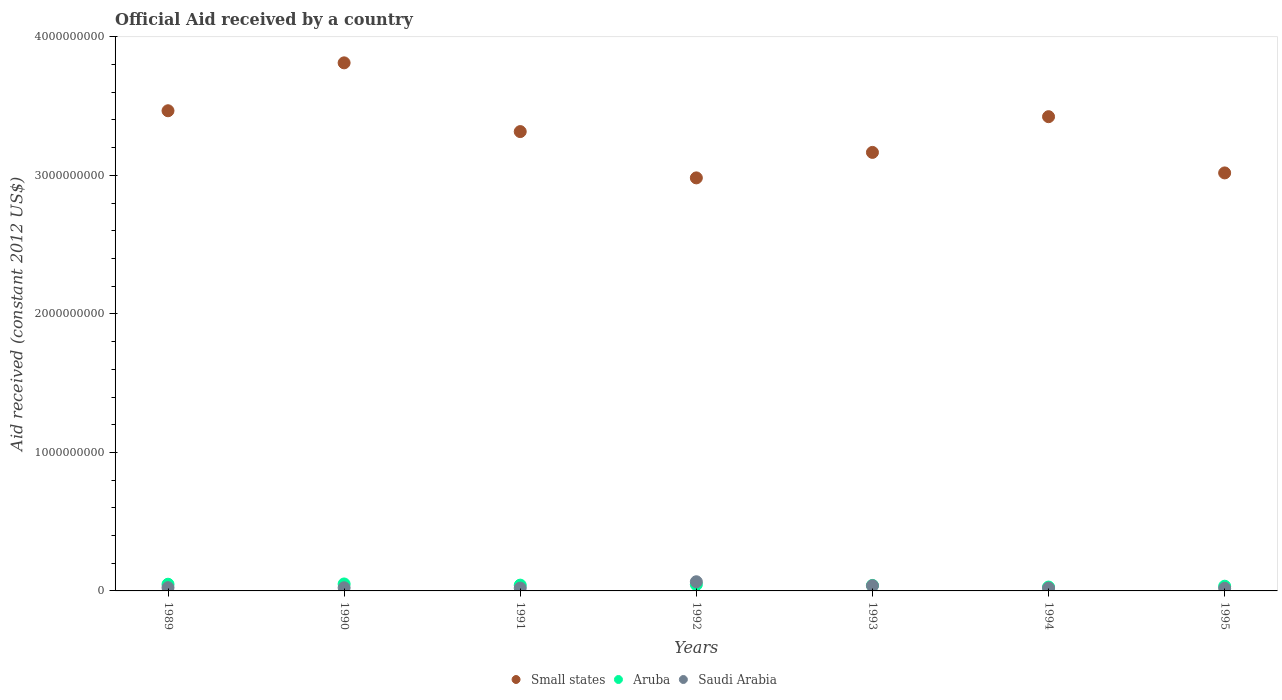How many different coloured dotlines are there?
Provide a short and direct response. 3. Is the number of dotlines equal to the number of legend labels?
Give a very brief answer. Yes. What is the net official aid received in Small states in 1995?
Offer a terse response. 3.02e+09. Across all years, what is the maximum net official aid received in Saudi Arabia?
Your answer should be very brief. 6.62e+07. Across all years, what is the minimum net official aid received in Saudi Arabia?
Ensure brevity in your answer.  1.89e+07. In which year was the net official aid received in Aruba maximum?
Provide a succinct answer. 1990. In which year was the net official aid received in Small states minimum?
Ensure brevity in your answer.  1992. What is the total net official aid received in Aruba in the graph?
Your answer should be very brief. 2.88e+08. What is the difference between the net official aid received in Saudi Arabia in 1989 and that in 1992?
Ensure brevity in your answer.  -4.27e+07. What is the difference between the net official aid received in Aruba in 1993 and the net official aid received in Small states in 1992?
Ensure brevity in your answer.  -2.94e+09. What is the average net official aid received in Saudi Arabia per year?
Ensure brevity in your answer.  3.00e+07. In the year 1990, what is the difference between the net official aid received in Small states and net official aid received in Saudi Arabia?
Offer a terse response. 3.79e+09. What is the ratio of the net official aid received in Aruba in 1989 to that in 1994?
Give a very brief answer. 1.74. Is the net official aid received in Small states in 1992 less than that in 1995?
Your response must be concise. Yes. Is the difference between the net official aid received in Small states in 1992 and 1993 greater than the difference between the net official aid received in Saudi Arabia in 1992 and 1993?
Provide a short and direct response. No. What is the difference between the highest and the second highest net official aid received in Aruba?
Give a very brief answer. 1.97e+06. What is the difference between the highest and the lowest net official aid received in Aruba?
Your response must be concise. 2.24e+07. Does the net official aid received in Aruba monotonically increase over the years?
Give a very brief answer. No. How many years are there in the graph?
Give a very brief answer. 7. Are the values on the major ticks of Y-axis written in scientific E-notation?
Your response must be concise. No. Where does the legend appear in the graph?
Offer a terse response. Bottom center. How many legend labels are there?
Your response must be concise. 3. What is the title of the graph?
Give a very brief answer. Official Aid received by a country. What is the label or title of the Y-axis?
Your response must be concise. Aid received (constant 2012 US$). What is the Aid received (constant 2012 US$) of Small states in 1989?
Provide a succinct answer. 3.47e+09. What is the Aid received (constant 2012 US$) in Aruba in 1989?
Make the answer very short. 4.83e+07. What is the Aid received (constant 2012 US$) of Saudi Arabia in 1989?
Ensure brevity in your answer.  2.34e+07. What is the Aid received (constant 2012 US$) of Small states in 1990?
Your response must be concise. 3.81e+09. What is the Aid received (constant 2012 US$) of Aruba in 1990?
Give a very brief answer. 5.03e+07. What is the Aid received (constant 2012 US$) of Saudi Arabia in 1990?
Make the answer very short. 2.27e+07. What is the Aid received (constant 2012 US$) of Small states in 1991?
Your response must be concise. 3.32e+09. What is the Aid received (constant 2012 US$) of Aruba in 1991?
Make the answer very short. 4.18e+07. What is the Aid received (constant 2012 US$) in Saudi Arabia in 1991?
Keep it short and to the point. 2.04e+07. What is the Aid received (constant 2012 US$) of Small states in 1992?
Your answer should be compact. 2.98e+09. What is the Aid received (constant 2012 US$) in Aruba in 1992?
Offer a very short reply. 4.60e+07. What is the Aid received (constant 2012 US$) in Saudi Arabia in 1992?
Provide a succinct answer. 6.62e+07. What is the Aid received (constant 2012 US$) of Small states in 1993?
Give a very brief answer. 3.17e+09. What is the Aid received (constant 2012 US$) of Aruba in 1993?
Your answer should be compact. 3.96e+07. What is the Aid received (constant 2012 US$) of Saudi Arabia in 1993?
Your answer should be compact. 3.77e+07. What is the Aid received (constant 2012 US$) in Small states in 1994?
Ensure brevity in your answer.  3.42e+09. What is the Aid received (constant 2012 US$) in Aruba in 1994?
Ensure brevity in your answer.  2.78e+07. What is the Aid received (constant 2012 US$) of Saudi Arabia in 1994?
Your answer should be very brief. 2.06e+07. What is the Aid received (constant 2012 US$) of Small states in 1995?
Keep it short and to the point. 3.02e+09. What is the Aid received (constant 2012 US$) of Aruba in 1995?
Provide a short and direct response. 3.40e+07. What is the Aid received (constant 2012 US$) in Saudi Arabia in 1995?
Make the answer very short. 1.89e+07. Across all years, what is the maximum Aid received (constant 2012 US$) of Small states?
Offer a very short reply. 3.81e+09. Across all years, what is the maximum Aid received (constant 2012 US$) of Aruba?
Offer a terse response. 5.03e+07. Across all years, what is the maximum Aid received (constant 2012 US$) in Saudi Arabia?
Give a very brief answer. 6.62e+07. Across all years, what is the minimum Aid received (constant 2012 US$) in Small states?
Offer a very short reply. 2.98e+09. Across all years, what is the minimum Aid received (constant 2012 US$) of Aruba?
Ensure brevity in your answer.  2.78e+07. Across all years, what is the minimum Aid received (constant 2012 US$) in Saudi Arabia?
Provide a short and direct response. 1.89e+07. What is the total Aid received (constant 2012 US$) of Small states in the graph?
Ensure brevity in your answer.  2.32e+1. What is the total Aid received (constant 2012 US$) of Aruba in the graph?
Keep it short and to the point. 2.88e+08. What is the total Aid received (constant 2012 US$) in Saudi Arabia in the graph?
Keep it short and to the point. 2.10e+08. What is the difference between the Aid received (constant 2012 US$) in Small states in 1989 and that in 1990?
Ensure brevity in your answer.  -3.46e+08. What is the difference between the Aid received (constant 2012 US$) of Aruba in 1989 and that in 1990?
Your response must be concise. -1.97e+06. What is the difference between the Aid received (constant 2012 US$) of Small states in 1989 and that in 1991?
Give a very brief answer. 1.50e+08. What is the difference between the Aid received (constant 2012 US$) of Aruba in 1989 and that in 1991?
Give a very brief answer. 6.55e+06. What is the difference between the Aid received (constant 2012 US$) of Saudi Arabia in 1989 and that in 1991?
Ensure brevity in your answer.  3.03e+06. What is the difference between the Aid received (constant 2012 US$) in Small states in 1989 and that in 1992?
Offer a terse response. 4.85e+08. What is the difference between the Aid received (constant 2012 US$) in Aruba in 1989 and that in 1992?
Make the answer very short. 2.31e+06. What is the difference between the Aid received (constant 2012 US$) in Saudi Arabia in 1989 and that in 1992?
Give a very brief answer. -4.27e+07. What is the difference between the Aid received (constant 2012 US$) of Small states in 1989 and that in 1993?
Your answer should be compact. 3.01e+08. What is the difference between the Aid received (constant 2012 US$) of Aruba in 1989 and that in 1993?
Your answer should be compact. 8.76e+06. What is the difference between the Aid received (constant 2012 US$) in Saudi Arabia in 1989 and that in 1993?
Keep it short and to the point. -1.42e+07. What is the difference between the Aid received (constant 2012 US$) in Small states in 1989 and that in 1994?
Make the answer very short. 4.28e+07. What is the difference between the Aid received (constant 2012 US$) in Aruba in 1989 and that in 1994?
Keep it short and to the point. 2.05e+07. What is the difference between the Aid received (constant 2012 US$) of Saudi Arabia in 1989 and that in 1994?
Offer a very short reply. 2.83e+06. What is the difference between the Aid received (constant 2012 US$) of Small states in 1989 and that in 1995?
Provide a succinct answer. 4.49e+08. What is the difference between the Aid received (constant 2012 US$) in Aruba in 1989 and that in 1995?
Keep it short and to the point. 1.43e+07. What is the difference between the Aid received (constant 2012 US$) in Saudi Arabia in 1989 and that in 1995?
Make the answer very short. 4.52e+06. What is the difference between the Aid received (constant 2012 US$) of Small states in 1990 and that in 1991?
Your answer should be very brief. 4.96e+08. What is the difference between the Aid received (constant 2012 US$) in Aruba in 1990 and that in 1991?
Make the answer very short. 8.52e+06. What is the difference between the Aid received (constant 2012 US$) of Saudi Arabia in 1990 and that in 1991?
Your answer should be very brief. 2.33e+06. What is the difference between the Aid received (constant 2012 US$) of Small states in 1990 and that in 1992?
Keep it short and to the point. 8.31e+08. What is the difference between the Aid received (constant 2012 US$) in Aruba in 1990 and that in 1992?
Offer a very short reply. 4.28e+06. What is the difference between the Aid received (constant 2012 US$) in Saudi Arabia in 1990 and that in 1992?
Your response must be concise. -4.34e+07. What is the difference between the Aid received (constant 2012 US$) of Small states in 1990 and that in 1993?
Provide a succinct answer. 6.47e+08. What is the difference between the Aid received (constant 2012 US$) in Aruba in 1990 and that in 1993?
Your response must be concise. 1.07e+07. What is the difference between the Aid received (constant 2012 US$) in Saudi Arabia in 1990 and that in 1993?
Provide a succinct answer. -1.50e+07. What is the difference between the Aid received (constant 2012 US$) of Small states in 1990 and that in 1994?
Give a very brief answer. 3.89e+08. What is the difference between the Aid received (constant 2012 US$) of Aruba in 1990 and that in 1994?
Your answer should be compact. 2.24e+07. What is the difference between the Aid received (constant 2012 US$) in Saudi Arabia in 1990 and that in 1994?
Keep it short and to the point. 2.13e+06. What is the difference between the Aid received (constant 2012 US$) of Small states in 1990 and that in 1995?
Ensure brevity in your answer.  7.95e+08. What is the difference between the Aid received (constant 2012 US$) of Aruba in 1990 and that in 1995?
Your answer should be very brief. 1.63e+07. What is the difference between the Aid received (constant 2012 US$) of Saudi Arabia in 1990 and that in 1995?
Offer a terse response. 3.82e+06. What is the difference between the Aid received (constant 2012 US$) of Small states in 1991 and that in 1992?
Ensure brevity in your answer.  3.34e+08. What is the difference between the Aid received (constant 2012 US$) in Aruba in 1991 and that in 1992?
Make the answer very short. -4.24e+06. What is the difference between the Aid received (constant 2012 US$) of Saudi Arabia in 1991 and that in 1992?
Give a very brief answer. -4.58e+07. What is the difference between the Aid received (constant 2012 US$) in Small states in 1991 and that in 1993?
Your answer should be compact. 1.50e+08. What is the difference between the Aid received (constant 2012 US$) in Aruba in 1991 and that in 1993?
Make the answer very short. 2.21e+06. What is the difference between the Aid received (constant 2012 US$) in Saudi Arabia in 1991 and that in 1993?
Make the answer very short. -1.73e+07. What is the difference between the Aid received (constant 2012 US$) in Small states in 1991 and that in 1994?
Your answer should be compact. -1.08e+08. What is the difference between the Aid received (constant 2012 US$) of Aruba in 1991 and that in 1994?
Keep it short and to the point. 1.39e+07. What is the difference between the Aid received (constant 2012 US$) of Small states in 1991 and that in 1995?
Ensure brevity in your answer.  2.98e+08. What is the difference between the Aid received (constant 2012 US$) in Aruba in 1991 and that in 1995?
Your answer should be very brief. 7.74e+06. What is the difference between the Aid received (constant 2012 US$) of Saudi Arabia in 1991 and that in 1995?
Offer a very short reply. 1.49e+06. What is the difference between the Aid received (constant 2012 US$) of Small states in 1992 and that in 1993?
Give a very brief answer. -1.84e+08. What is the difference between the Aid received (constant 2012 US$) of Aruba in 1992 and that in 1993?
Give a very brief answer. 6.45e+06. What is the difference between the Aid received (constant 2012 US$) in Saudi Arabia in 1992 and that in 1993?
Offer a very short reply. 2.85e+07. What is the difference between the Aid received (constant 2012 US$) of Small states in 1992 and that in 1994?
Make the answer very short. -4.42e+08. What is the difference between the Aid received (constant 2012 US$) in Aruba in 1992 and that in 1994?
Give a very brief answer. 1.82e+07. What is the difference between the Aid received (constant 2012 US$) of Saudi Arabia in 1992 and that in 1994?
Your response must be concise. 4.56e+07. What is the difference between the Aid received (constant 2012 US$) in Small states in 1992 and that in 1995?
Ensure brevity in your answer.  -3.59e+07. What is the difference between the Aid received (constant 2012 US$) of Aruba in 1992 and that in 1995?
Your response must be concise. 1.20e+07. What is the difference between the Aid received (constant 2012 US$) of Saudi Arabia in 1992 and that in 1995?
Give a very brief answer. 4.73e+07. What is the difference between the Aid received (constant 2012 US$) in Small states in 1993 and that in 1994?
Your response must be concise. -2.58e+08. What is the difference between the Aid received (constant 2012 US$) of Aruba in 1993 and that in 1994?
Your response must be concise. 1.17e+07. What is the difference between the Aid received (constant 2012 US$) in Saudi Arabia in 1993 and that in 1994?
Your response must be concise. 1.71e+07. What is the difference between the Aid received (constant 2012 US$) in Small states in 1993 and that in 1995?
Offer a terse response. 1.48e+08. What is the difference between the Aid received (constant 2012 US$) of Aruba in 1993 and that in 1995?
Your answer should be very brief. 5.53e+06. What is the difference between the Aid received (constant 2012 US$) in Saudi Arabia in 1993 and that in 1995?
Give a very brief answer. 1.88e+07. What is the difference between the Aid received (constant 2012 US$) of Small states in 1994 and that in 1995?
Give a very brief answer. 4.06e+08. What is the difference between the Aid received (constant 2012 US$) in Aruba in 1994 and that in 1995?
Make the answer very short. -6.18e+06. What is the difference between the Aid received (constant 2012 US$) of Saudi Arabia in 1994 and that in 1995?
Your answer should be compact. 1.69e+06. What is the difference between the Aid received (constant 2012 US$) in Small states in 1989 and the Aid received (constant 2012 US$) in Aruba in 1990?
Offer a terse response. 3.42e+09. What is the difference between the Aid received (constant 2012 US$) in Small states in 1989 and the Aid received (constant 2012 US$) in Saudi Arabia in 1990?
Offer a very short reply. 3.44e+09. What is the difference between the Aid received (constant 2012 US$) of Aruba in 1989 and the Aid received (constant 2012 US$) of Saudi Arabia in 1990?
Your response must be concise. 2.56e+07. What is the difference between the Aid received (constant 2012 US$) of Small states in 1989 and the Aid received (constant 2012 US$) of Aruba in 1991?
Ensure brevity in your answer.  3.42e+09. What is the difference between the Aid received (constant 2012 US$) of Small states in 1989 and the Aid received (constant 2012 US$) of Saudi Arabia in 1991?
Make the answer very short. 3.45e+09. What is the difference between the Aid received (constant 2012 US$) in Aruba in 1989 and the Aid received (constant 2012 US$) in Saudi Arabia in 1991?
Make the answer very short. 2.79e+07. What is the difference between the Aid received (constant 2012 US$) of Small states in 1989 and the Aid received (constant 2012 US$) of Aruba in 1992?
Give a very brief answer. 3.42e+09. What is the difference between the Aid received (constant 2012 US$) of Small states in 1989 and the Aid received (constant 2012 US$) of Saudi Arabia in 1992?
Your answer should be very brief. 3.40e+09. What is the difference between the Aid received (constant 2012 US$) of Aruba in 1989 and the Aid received (constant 2012 US$) of Saudi Arabia in 1992?
Ensure brevity in your answer.  -1.78e+07. What is the difference between the Aid received (constant 2012 US$) in Small states in 1989 and the Aid received (constant 2012 US$) in Aruba in 1993?
Provide a succinct answer. 3.43e+09. What is the difference between the Aid received (constant 2012 US$) of Small states in 1989 and the Aid received (constant 2012 US$) of Saudi Arabia in 1993?
Ensure brevity in your answer.  3.43e+09. What is the difference between the Aid received (constant 2012 US$) of Aruba in 1989 and the Aid received (constant 2012 US$) of Saudi Arabia in 1993?
Your answer should be very brief. 1.06e+07. What is the difference between the Aid received (constant 2012 US$) in Small states in 1989 and the Aid received (constant 2012 US$) in Aruba in 1994?
Your response must be concise. 3.44e+09. What is the difference between the Aid received (constant 2012 US$) in Small states in 1989 and the Aid received (constant 2012 US$) in Saudi Arabia in 1994?
Offer a very short reply. 3.45e+09. What is the difference between the Aid received (constant 2012 US$) of Aruba in 1989 and the Aid received (constant 2012 US$) of Saudi Arabia in 1994?
Make the answer very short. 2.77e+07. What is the difference between the Aid received (constant 2012 US$) of Small states in 1989 and the Aid received (constant 2012 US$) of Aruba in 1995?
Keep it short and to the point. 3.43e+09. What is the difference between the Aid received (constant 2012 US$) of Small states in 1989 and the Aid received (constant 2012 US$) of Saudi Arabia in 1995?
Make the answer very short. 3.45e+09. What is the difference between the Aid received (constant 2012 US$) of Aruba in 1989 and the Aid received (constant 2012 US$) of Saudi Arabia in 1995?
Your answer should be very brief. 2.94e+07. What is the difference between the Aid received (constant 2012 US$) of Small states in 1990 and the Aid received (constant 2012 US$) of Aruba in 1991?
Give a very brief answer. 3.77e+09. What is the difference between the Aid received (constant 2012 US$) of Small states in 1990 and the Aid received (constant 2012 US$) of Saudi Arabia in 1991?
Your answer should be very brief. 3.79e+09. What is the difference between the Aid received (constant 2012 US$) of Aruba in 1990 and the Aid received (constant 2012 US$) of Saudi Arabia in 1991?
Keep it short and to the point. 2.99e+07. What is the difference between the Aid received (constant 2012 US$) in Small states in 1990 and the Aid received (constant 2012 US$) in Aruba in 1992?
Offer a very short reply. 3.77e+09. What is the difference between the Aid received (constant 2012 US$) of Small states in 1990 and the Aid received (constant 2012 US$) of Saudi Arabia in 1992?
Ensure brevity in your answer.  3.75e+09. What is the difference between the Aid received (constant 2012 US$) of Aruba in 1990 and the Aid received (constant 2012 US$) of Saudi Arabia in 1992?
Your response must be concise. -1.59e+07. What is the difference between the Aid received (constant 2012 US$) of Small states in 1990 and the Aid received (constant 2012 US$) of Aruba in 1993?
Offer a terse response. 3.77e+09. What is the difference between the Aid received (constant 2012 US$) of Small states in 1990 and the Aid received (constant 2012 US$) of Saudi Arabia in 1993?
Offer a very short reply. 3.77e+09. What is the difference between the Aid received (constant 2012 US$) in Aruba in 1990 and the Aid received (constant 2012 US$) in Saudi Arabia in 1993?
Your answer should be compact. 1.26e+07. What is the difference between the Aid received (constant 2012 US$) of Small states in 1990 and the Aid received (constant 2012 US$) of Aruba in 1994?
Give a very brief answer. 3.78e+09. What is the difference between the Aid received (constant 2012 US$) of Small states in 1990 and the Aid received (constant 2012 US$) of Saudi Arabia in 1994?
Offer a terse response. 3.79e+09. What is the difference between the Aid received (constant 2012 US$) in Aruba in 1990 and the Aid received (constant 2012 US$) in Saudi Arabia in 1994?
Provide a short and direct response. 2.97e+07. What is the difference between the Aid received (constant 2012 US$) of Small states in 1990 and the Aid received (constant 2012 US$) of Aruba in 1995?
Provide a succinct answer. 3.78e+09. What is the difference between the Aid received (constant 2012 US$) of Small states in 1990 and the Aid received (constant 2012 US$) of Saudi Arabia in 1995?
Your answer should be compact. 3.79e+09. What is the difference between the Aid received (constant 2012 US$) of Aruba in 1990 and the Aid received (constant 2012 US$) of Saudi Arabia in 1995?
Your answer should be very brief. 3.14e+07. What is the difference between the Aid received (constant 2012 US$) of Small states in 1991 and the Aid received (constant 2012 US$) of Aruba in 1992?
Offer a very short reply. 3.27e+09. What is the difference between the Aid received (constant 2012 US$) in Small states in 1991 and the Aid received (constant 2012 US$) in Saudi Arabia in 1992?
Make the answer very short. 3.25e+09. What is the difference between the Aid received (constant 2012 US$) in Aruba in 1991 and the Aid received (constant 2012 US$) in Saudi Arabia in 1992?
Offer a terse response. -2.44e+07. What is the difference between the Aid received (constant 2012 US$) in Small states in 1991 and the Aid received (constant 2012 US$) in Aruba in 1993?
Your answer should be very brief. 3.28e+09. What is the difference between the Aid received (constant 2012 US$) in Small states in 1991 and the Aid received (constant 2012 US$) in Saudi Arabia in 1993?
Keep it short and to the point. 3.28e+09. What is the difference between the Aid received (constant 2012 US$) of Aruba in 1991 and the Aid received (constant 2012 US$) of Saudi Arabia in 1993?
Offer a terse response. 4.09e+06. What is the difference between the Aid received (constant 2012 US$) in Small states in 1991 and the Aid received (constant 2012 US$) in Aruba in 1994?
Your answer should be compact. 3.29e+09. What is the difference between the Aid received (constant 2012 US$) in Small states in 1991 and the Aid received (constant 2012 US$) in Saudi Arabia in 1994?
Make the answer very short. 3.30e+09. What is the difference between the Aid received (constant 2012 US$) of Aruba in 1991 and the Aid received (constant 2012 US$) of Saudi Arabia in 1994?
Give a very brief answer. 2.12e+07. What is the difference between the Aid received (constant 2012 US$) of Small states in 1991 and the Aid received (constant 2012 US$) of Aruba in 1995?
Your answer should be compact. 3.28e+09. What is the difference between the Aid received (constant 2012 US$) in Small states in 1991 and the Aid received (constant 2012 US$) in Saudi Arabia in 1995?
Provide a succinct answer. 3.30e+09. What is the difference between the Aid received (constant 2012 US$) of Aruba in 1991 and the Aid received (constant 2012 US$) of Saudi Arabia in 1995?
Make the answer very short. 2.29e+07. What is the difference between the Aid received (constant 2012 US$) in Small states in 1992 and the Aid received (constant 2012 US$) in Aruba in 1993?
Offer a very short reply. 2.94e+09. What is the difference between the Aid received (constant 2012 US$) in Small states in 1992 and the Aid received (constant 2012 US$) in Saudi Arabia in 1993?
Ensure brevity in your answer.  2.94e+09. What is the difference between the Aid received (constant 2012 US$) of Aruba in 1992 and the Aid received (constant 2012 US$) of Saudi Arabia in 1993?
Make the answer very short. 8.33e+06. What is the difference between the Aid received (constant 2012 US$) in Small states in 1992 and the Aid received (constant 2012 US$) in Aruba in 1994?
Your answer should be compact. 2.95e+09. What is the difference between the Aid received (constant 2012 US$) of Small states in 1992 and the Aid received (constant 2012 US$) of Saudi Arabia in 1994?
Your answer should be very brief. 2.96e+09. What is the difference between the Aid received (constant 2012 US$) in Aruba in 1992 and the Aid received (constant 2012 US$) in Saudi Arabia in 1994?
Your answer should be compact. 2.54e+07. What is the difference between the Aid received (constant 2012 US$) in Small states in 1992 and the Aid received (constant 2012 US$) in Aruba in 1995?
Offer a very short reply. 2.95e+09. What is the difference between the Aid received (constant 2012 US$) in Small states in 1992 and the Aid received (constant 2012 US$) in Saudi Arabia in 1995?
Make the answer very short. 2.96e+09. What is the difference between the Aid received (constant 2012 US$) of Aruba in 1992 and the Aid received (constant 2012 US$) of Saudi Arabia in 1995?
Provide a succinct answer. 2.71e+07. What is the difference between the Aid received (constant 2012 US$) in Small states in 1993 and the Aid received (constant 2012 US$) in Aruba in 1994?
Provide a short and direct response. 3.14e+09. What is the difference between the Aid received (constant 2012 US$) of Small states in 1993 and the Aid received (constant 2012 US$) of Saudi Arabia in 1994?
Your answer should be compact. 3.15e+09. What is the difference between the Aid received (constant 2012 US$) of Aruba in 1993 and the Aid received (constant 2012 US$) of Saudi Arabia in 1994?
Your answer should be very brief. 1.90e+07. What is the difference between the Aid received (constant 2012 US$) of Small states in 1993 and the Aid received (constant 2012 US$) of Aruba in 1995?
Give a very brief answer. 3.13e+09. What is the difference between the Aid received (constant 2012 US$) of Small states in 1993 and the Aid received (constant 2012 US$) of Saudi Arabia in 1995?
Your response must be concise. 3.15e+09. What is the difference between the Aid received (constant 2012 US$) in Aruba in 1993 and the Aid received (constant 2012 US$) in Saudi Arabia in 1995?
Make the answer very short. 2.06e+07. What is the difference between the Aid received (constant 2012 US$) of Small states in 1994 and the Aid received (constant 2012 US$) of Aruba in 1995?
Offer a terse response. 3.39e+09. What is the difference between the Aid received (constant 2012 US$) of Small states in 1994 and the Aid received (constant 2012 US$) of Saudi Arabia in 1995?
Provide a succinct answer. 3.40e+09. What is the difference between the Aid received (constant 2012 US$) in Aruba in 1994 and the Aid received (constant 2012 US$) in Saudi Arabia in 1995?
Your response must be concise. 8.94e+06. What is the average Aid received (constant 2012 US$) in Small states per year?
Give a very brief answer. 3.31e+09. What is the average Aid received (constant 2012 US$) in Aruba per year?
Give a very brief answer. 4.11e+07. What is the average Aid received (constant 2012 US$) in Saudi Arabia per year?
Give a very brief answer. 3.00e+07. In the year 1989, what is the difference between the Aid received (constant 2012 US$) in Small states and Aid received (constant 2012 US$) in Aruba?
Your answer should be very brief. 3.42e+09. In the year 1989, what is the difference between the Aid received (constant 2012 US$) in Small states and Aid received (constant 2012 US$) in Saudi Arabia?
Your answer should be compact. 3.44e+09. In the year 1989, what is the difference between the Aid received (constant 2012 US$) of Aruba and Aid received (constant 2012 US$) of Saudi Arabia?
Offer a very short reply. 2.49e+07. In the year 1990, what is the difference between the Aid received (constant 2012 US$) in Small states and Aid received (constant 2012 US$) in Aruba?
Offer a very short reply. 3.76e+09. In the year 1990, what is the difference between the Aid received (constant 2012 US$) in Small states and Aid received (constant 2012 US$) in Saudi Arabia?
Make the answer very short. 3.79e+09. In the year 1990, what is the difference between the Aid received (constant 2012 US$) of Aruba and Aid received (constant 2012 US$) of Saudi Arabia?
Provide a succinct answer. 2.76e+07. In the year 1991, what is the difference between the Aid received (constant 2012 US$) in Small states and Aid received (constant 2012 US$) in Aruba?
Your response must be concise. 3.27e+09. In the year 1991, what is the difference between the Aid received (constant 2012 US$) in Small states and Aid received (constant 2012 US$) in Saudi Arabia?
Provide a succinct answer. 3.30e+09. In the year 1991, what is the difference between the Aid received (constant 2012 US$) of Aruba and Aid received (constant 2012 US$) of Saudi Arabia?
Your answer should be very brief. 2.14e+07. In the year 1992, what is the difference between the Aid received (constant 2012 US$) of Small states and Aid received (constant 2012 US$) of Aruba?
Your answer should be very brief. 2.94e+09. In the year 1992, what is the difference between the Aid received (constant 2012 US$) of Small states and Aid received (constant 2012 US$) of Saudi Arabia?
Offer a terse response. 2.92e+09. In the year 1992, what is the difference between the Aid received (constant 2012 US$) in Aruba and Aid received (constant 2012 US$) in Saudi Arabia?
Give a very brief answer. -2.02e+07. In the year 1993, what is the difference between the Aid received (constant 2012 US$) of Small states and Aid received (constant 2012 US$) of Aruba?
Your answer should be very brief. 3.13e+09. In the year 1993, what is the difference between the Aid received (constant 2012 US$) of Small states and Aid received (constant 2012 US$) of Saudi Arabia?
Make the answer very short. 3.13e+09. In the year 1993, what is the difference between the Aid received (constant 2012 US$) in Aruba and Aid received (constant 2012 US$) in Saudi Arabia?
Your response must be concise. 1.88e+06. In the year 1994, what is the difference between the Aid received (constant 2012 US$) in Small states and Aid received (constant 2012 US$) in Aruba?
Ensure brevity in your answer.  3.40e+09. In the year 1994, what is the difference between the Aid received (constant 2012 US$) in Small states and Aid received (constant 2012 US$) in Saudi Arabia?
Your answer should be very brief. 3.40e+09. In the year 1994, what is the difference between the Aid received (constant 2012 US$) of Aruba and Aid received (constant 2012 US$) of Saudi Arabia?
Keep it short and to the point. 7.25e+06. In the year 1995, what is the difference between the Aid received (constant 2012 US$) in Small states and Aid received (constant 2012 US$) in Aruba?
Your answer should be compact. 2.98e+09. In the year 1995, what is the difference between the Aid received (constant 2012 US$) in Small states and Aid received (constant 2012 US$) in Saudi Arabia?
Keep it short and to the point. 3.00e+09. In the year 1995, what is the difference between the Aid received (constant 2012 US$) in Aruba and Aid received (constant 2012 US$) in Saudi Arabia?
Give a very brief answer. 1.51e+07. What is the ratio of the Aid received (constant 2012 US$) of Small states in 1989 to that in 1990?
Keep it short and to the point. 0.91. What is the ratio of the Aid received (constant 2012 US$) of Aruba in 1989 to that in 1990?
Your answer should be compact. 0.96. What is the ratio of the Aid received (constant 2012 US$) in Saudi Arabia in 1989 to that in 1990?
Your answer should be compact. 1.03. What is the ratio of the Aid received (constant 2012 US$) in Small states in 1989 to that in 1991?
Your answer should be compact. 1.05. What is the ratio of the Aid received (constant 2012 US$) in Aruba in 1989 to that in 1991?
Your answer should be very brief. 1.16. What is the ratio of the Aid received (constant 2012 US$) of Saudi Arabia in 1989 to that in 1991?
Provide a succinct answer. 1.15. What is the ratio of the Aid received (constant 2012 US$) in Small states in 1989 to that in 1992?
Keep it short and to the point. 1.16. What is the ratio of the Aid received (constant 2012 US$) in Aruba in 1989 to that in 1992?
Provide a short and direct response. 1.05. What is the ratio of the Aid received (constant 2012 US$) in Saudi Arabia in 1989 to that in 1992?
Your response must be concise. 0.35. What is the ratio of the Aid received (constant 2012 US$) of Small states in 1989 to that in 1993?
Give a very brief answer. 1.09. What is the ratio of the Aid received (constant 2012 US$) of Aruba in 1989 to that in 1993?
Keep it short and to the point. 1.22. What is the ratio of the Aid received (constant 2012 US$) of Saudi Arabia in 1989 to that in 1993?
Keep it short and to the point. 0.62. What is the ratio of the Aid received (constant 2012 US$) in Small states in 1989 to that in 1994?
Give a very brief answer. 1.01. What is the ratio of the Aid received (constant 2012 US$) of Aruba in 1989 to that in 1994?
Your response must be concise. 1.74. What is the ratio of the Aid received (constant 2012 US$) of Saudi Arabia in 1989 to that in 1994?
Provide a succinct answer. 1.14. What is the ratio of the Aid received (constant 2012 US$) of Small states in 1989 to that in 1995?
Provide a succinct answer. 1.15. What is the ratio of the Aid received (constant 2012 US$) of Aruba in 1989 to that in 1995?
Your answer should be very brief. 1.42. What is the ratio of the Aid received (constant 2012 US$) of Saudi Arabia in 1989 to that in 1995?
Provide a succinct answer. 1.24. What is the ratio of the Aid received (constant 2012 US$) of Small states in 1990 to that in 1991?
Offer a very short reply. 1.15. What is the ratio of the Aid received (constant 2012 US$) in Aruba in 1990 to that in 1991?
Give a very brief answer. 1.2. What is the ratio of the Aid received (constant 2012 US$) in Saudi Arabia in 1990 to that in 1991?
Your answer should be very brief. 1.11. What is the ratio of the Aid received (constant 2012 US$) in Small states in 1990 to that in 1992?
Keep it short and to the point. 1.28. What is the ratio of the Aid received (constant 2012 US$) in Aruba in 1990 to that in 1992?
Keep it short and to the point. 1.09. What is the ratio of the Aid received (constant 2012 US$) of Saudi Arabia in 1990 to that in 1992?
Your answer should be compact. 0.34. What is the ratio of the Aid received (constant 2012 US$) in Small states in 1990 to that in 1993?
Keep it short and to the point. 1.2. What is the ratio of the Aid received (constant 2012 US$) of Aruba in 1990 to that in 1993?
Give a very brief answer. 1.27. What is the ratio of the Aid received (constant 2012 US$) in Saudi Arabia in 1990 to that in 1993?
Ensure brevity in your answer.  0.6. What is the ratio of the Aid received (constant 2012 US$) in Small states in 1990 to that in 1994?
Offer a very short reply. 1.11. What is the ratio of the Aid received (constant 2012 US$) of Aruba in 1990 to that in 1994?
Your answer should be very brief. 1.81. What is the ratio of the Aid received (constant 2012 US$) in Saudi Arabia in 1990 to that in 1994?
Offer a terse response. 1.1. What is the ratio of the Aid received (constant 2012 US$) in Small states in 1990 to that in 1995?
Your answer should be compact. 1.26. What is the ratio of the Aid received (constant 2012 US$) in Aruba in 1990 to that in 1995?
Your response must be concise. 1.48. What is the ratio of the Aid received (constant 2012 US$) in Saudi Arabia in 1990 to that in 1995?
Offer a very short reply. 1.2. What is the ratio of the Aid received (constant 2012 US$) of Small states in 1991 to that in 1992?
Ensure brevity in your answer.  1.11. What is the ratio of the Aid received (constant 2012 US$) of Aruba in 1991 to that in 1992?
Offer a terse response. 0.91. What is the ratio of the Aid received (constant 2012 US$) of Saudi Arabia in 1991 to that in 1992?
Keep it short and to the point. 0.31. What is the ratio of the Aid received (constant 2012 US$) of Small states in 1991 to that in 1993?
Make the answer very short. 1.05. What is the ratio of the Aid received (constant 2012 US$) of Aruba in 1991 to that in 1993?
Keep it short and to the point. 1.06. What is the ratio of the Aid received (constant 2012 US$) of Saudi Arabia in 1991 to that in 1993?
Ensure brevity in your answer.  0.54. What is the ratio of the Aid received (constant 2012 US$) in Small states in 1991 to that in 1994?
Give a very brief answer. 0.97. What is the ratio of the Aid received (constant 2012 US$) of Saudi Arabia in 1991 to that in 1994?
Give a very brief answer. 0.99. What is the ratio of the Aid received (constant 2012 US$) in Small states in 1991 to that in 1995?
Make the answer very short. 1.1. What is the ratio of the Aid received (constant 2012 US$) in Aruba in 1991 to that in 1995?
Your response must be concise. 1.23. What is the ratio of the Aid received (constant 2012 US$) of Saudi Arabia in 1991 to that in 1995?
Your answer should be compact. 1.08. What is the ratio of the Aid received (constant 2012 US$) of Small states in 1992 to that in 1993?
Your response must be concise. 0.94. What is the ratio of the Aid received (constant 2012 US$) of Aruba in 1992 to that in 1993?
Offer a terse response. 1.16. What is the ratio of the Aid received (constant 2012 US$) in Saudi Arabia in 1992 to that in 1993?
Provide a short and direct response. 1.76. What is the ratio of the Aid received (constant 2012 US$) of Small states in 1992 to that in 1994?
Keep it short and to the point. 0.87. What is the ratio of the Aid received (constant 2012 US$) of Aruba in 1992 to that in 1994?
Your response must be concise. 1.65. What is the ratio of the Aid received (constant 2012 US$) in Saudi Arabia in 1992 to that in 1994?
Provide a succinct answer. 3.21. What is the ratio of the Aid received (constant 2012 US$) in Small states in 1992 to that in 1995?
Your answer should be very brief. 0.99. What is the ratio of the Aid received (constant 2012 US$) in Aruba in 1992 to that in 1995?
Ensure brevity in your answer.  1.35. What is the ratio of the Aid received (constant 2012 US$) of Saudi Arabia in 1992 to that in 1995?
Offer a very short reply. 3.5. What is the ratio of the Aid received (constant 2012 US$) of Small states in 1993 to that in 1994?
Keep it short and to the point. 0.92. What is the ratio of the Aid received (constant 2012 US$) of Aruba in 1993 to that in 1994?
Your answer should be compact. 1.42. What is the ratio of the Aid received (constant 2012 US$) of Saudi Arabia in 1993 to that in 1994?
Provide a succinct answer. 1.83. What is the ratio of the Aid received (constant 2012 US$) in Small states in 1993 to that in 1995?
Your answer should be compact. 1.05. What is the ratio of the Aid received (constant 2012 US$) in Aruba in 1993 to that in 1995?
Offer a terse response. 1.16. What is the ratio of the Aid received (constant 2012 US$) of Saudi Arabia in 1993 to that in 1995?
Make the answer very short. 1.99. What is the ratio of the Aid received (constant 2012 US$) of Small states in 1994 to that in 1995?
Provide a short and direct response. 1.13. What is the ratio of the Aid received (constant 2012 US$) in Aruba in 1994 to that in 1995?
Offer a terse response. 0.82. What is the ratio of the Aid received (constant 2012 US$) in Saudi Arabia in 1994 to that in 1995?
Provide a short and direct response. 1.09. What is the difference between the highest and the second highest Aid received (constant 2012 US$) in Small states?
Your answer should be very brief. 3.46e+08. What is the difference between the highest and the second highest Aid received (constant 2012 US$) of Aruba?
Your answer should be compact. 1.97e+06. What is the difference between the highest and the second highest Aid received (constant 2012 US$) of Saudi Arabia?
Offer a terse response. 2.85e+07. What is the difference between the highest and the lowest Aid received (constant 2012 US$) in Small states?
Your answer should be compact. 8.31e+08. What is the difference between the highest and the lowest Aid received (constant 2012 US$) of Aruba?
Ensure brevity in your answer.  2.24e+07. What is the difference between the highest and the lowest Aid received (constant 2012 US$) in Saudi Arabia?
Ensure brevity in your answer.  4.73e+07. 